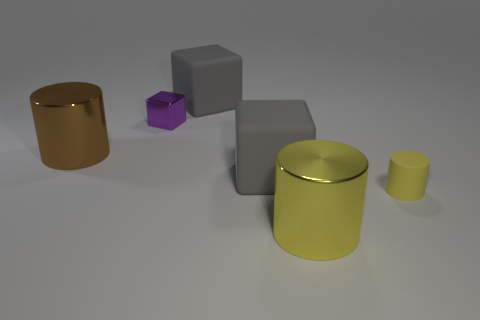Which object looks closest to the camera? The yellow cylinder appears closest to the camera, standing out prominently with its bright color and reflective surface. What does the positioning of objects tell us about perspective? The arrangement of the objects gives us clues about the perspective; the varying sizes and overlaps create a sense of depth and three-dimensionality in the image. 